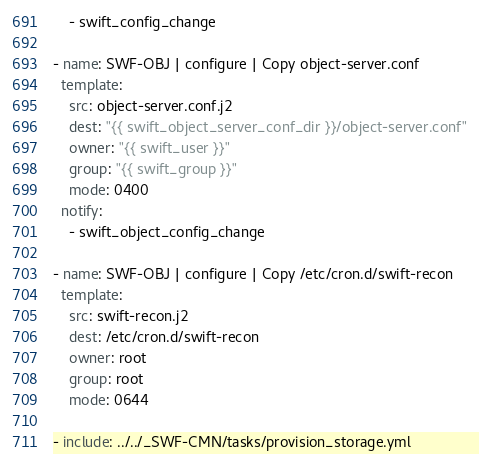<code> <loc_0><loc_0><loc_500><loc_500><_YAML_>    - swift_config_change

- name: SWF-OBJ | configure | Copy object-server.conf
  template:
    src: object-server.conf.j2
    dest: "{{ swift_object_server_conf_dir }}/object-server.conf"
    owner: "{{ swift_user }}"
    group: "{{ swift_group }}"
    mode: 0400
  notify:
    - swift_object_config_change

- name: SWF-OBJ | configure | Copy /etc/cron.d/swift-recon
  template:
    src: swift-recon.j2
    dest: /etc/cron.d/swift-recon
    owner: root
    group: root
    mode: 0644

- include: ../../_SWF-CMN/tasks/provision_storage.yml
</code> 